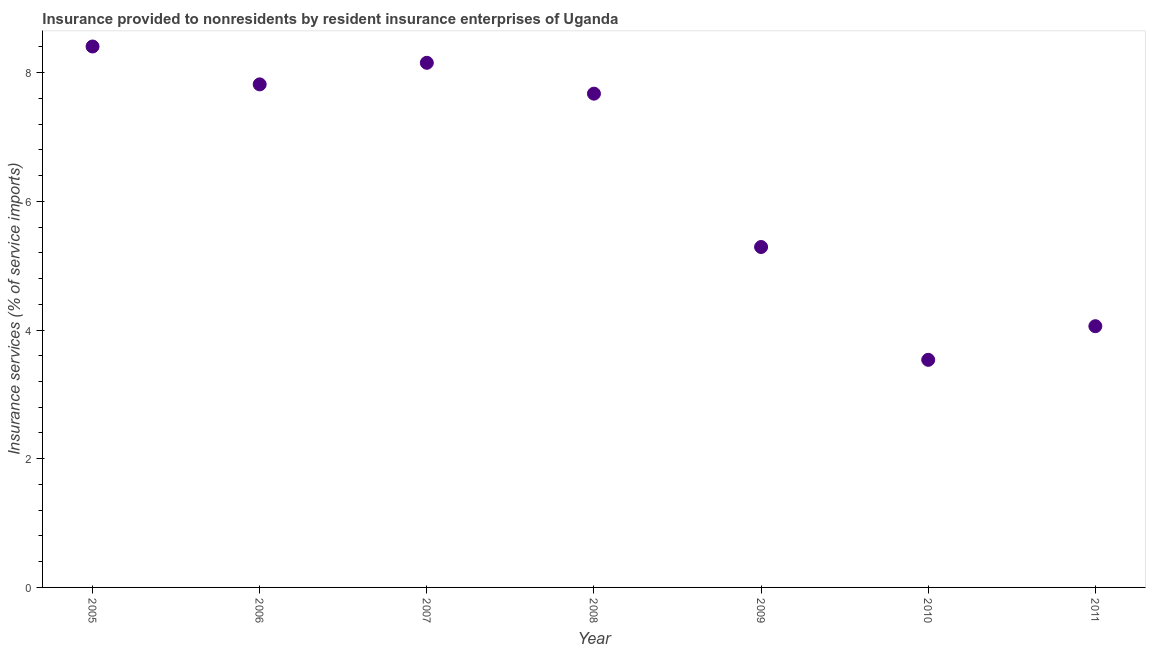What is the insurance and financial services in 2011?
Offer a very short reply. 4.06. Across all years, what is the maximum insurance and financial services?
Offer a terse response. 8.41. Across all years, what is the minimum insurance and financial services?
Provide a succinct answer. 3.54. What is the sum of the insurance and financial services?
Your answer should be very brief. 44.94. What is the difference between the insurance and financial services in 2007 and 2010?
Ensure brevity in your answer.  4.62. What is the average insurance and financial services per year?
Keep it short and to the point. 6.42. What is the median insurance and financial services?
Your response must be concise. 7.67. What is the ratio of the insurance and financial services in 2005 to that in 2007?
Your response must be concise. 1.03. Is the insurance and financial services in 2010 less than that in 2011?
Ensure brevity in your answer.  Yes. Is the difference between the insurance and financial services in 2005 and 2011 greater than the difference between any two years?
Make the answer very short. No. What is the difference between the highest and the second highest insurance and financial services?
Your response must be concise. 0.25. What is the difference between the highest and the lowest insurance and financial services?
Provide a short and direct response. 4.87. In how many years, is the insurance and financial services greater than the average insurance and financial services taken over all years?
Give a very brief answer. 4. How many dotlines are there?
Offer a terse response. 1. How many years are there in the graph?
Your answer should be compact. 7. What is the difference between two consecutive major ticks on the Y-axis?
Your answer should be very brief. 2. Does the graph contain any zero values?
Make the answer very short. No. What is the title of the graph?
Offer a terse response. Insurance provided to nonresidents by resident insurance enterprises of Uganda. What is the label or title of the X-axis?
Your answer should be compact. Year. What is the label or title of the Y-axis?
Your answer should be compact. Insurance services (% of service imports). What is the Insurance services (% of service imports) in 2005?
Give a very brief answer. 8.41. What is the Insurance services (% of service imports) in 2006?
Make the answer very short. 7.82. What is the Insurance services (% of service imports) in 2007?
Your answer should be very brief. 8.15. What is the Insurance services (% of service imports) in 2008?
Ensure brevity in your answer.  7.67. What is the Insurance services (% of service imports) in 2009?
Keep it short and to the point. 5.29. What is the Insurance services (% of service imports) in 2010?
Ensure brevity in your answer.  3.54. What is the Insurance services (% of service imports) in 2011?
Keep it short and to the point. 4.06. What is the difference between the Insurance services (% of service imports) in 2005 and 2006?
Offer a very short reply. 0.59. What is the difference between the Insurance services (% of service imports) in 2005 and 2007?
Make the answer very short. 0.25. What is the difference between the Insurance services (% of service imports) in 2005 and 2008?
Offer a terse response. 0.73. What is the difference between the Insurance services (% of service imports) in 2005 and 2009?
Ensure brevity in your answer.  3.12. What is the difference between the Insurance services (% of service imports) in 2005 and 2010?
Give a very brief answer. 4.87. What is the difference between the Insurance services (% of service imports) in 2005 and 2011?
Offer a very short reply. 4.35. What is the difference between the Insurance services (% of service imports) in 2006 and 2007?
Keep it short and to the point. -0.34. What is the difference between the Insurance services (% of service imports) in 2006 and 2008?
Ensure brevity in your answer.  0.14. What is the difference between the Insurance services (% of service imports) in 2006 and 2009?
Your response must be concise. 2.53. What is the difference between the Insurance services (% of service imports) in 2006 and 2010?
Offer a very short reply. 4.28. What is the difference between the Insurance services (% of service imports) in 2006 and 2011?
Give a very brief answer. 3.76. What is the difference between the Insurance services (% of service imports) in 2007 and 2008?
Your response must be concise. 0.48. What is the difference between the Insurance services (% of service imports) in 2007 and 2009?
Your answer should be compact. 2.86. What is the difference between the Insurance services (% of service imports) in 2007 and 2010?
Make the answer very short. 4.62. What is the difference between the Insurance services (% of service imports) in 2007 and 2011?
Keep it short and to the point. 4.09. What is the difference between the Insurance services (% of service imports) in 2008 and 2009?
Keep it short and to the point. 2.38. What is the difference between the Insurance services (% of service imports) in 2008 and 2010?
Offer a terse response. 4.14. What is the difference between the Insurance services (% of service imports) in 2008 and 2011?
Your answer should be compact. 3.61. What is the difference between the Insurance services (% of service imports) in 2009 and 2010?
Ensure brevity in your answer.  1.75. What is the difference between the Insurance services (% of service imports) in 2009 and 2011?
Your response must be concise. 1.23. What is the difference between the Insurance services (% of service imports) in 2010 and 2011?
Provide a succinct answer. -0.52. What is the ratio of the Insurance services (% of service imports) in 2005 to that in 2006?
Make the answer very short. 1.07. What is the ratio of the Insurance services (% of service imports) in 2005 to that in 2007?
Offer a very short reply. 1.03. What is the ratio of the Insurance services (% of service imports) in 2005 to that in 2008?
Your answer should be very brief. 1.1. What is the ratio of the Insurance services (% of service imports) in 2005 to that in 2009?
Offer a very short reply. 1.59. What is the ratio of the Insurance services (% of service imports) in 2005 to that in 2010?
Keep it short and to the point. 2.38. What is the ratio of the Insurance services (% of service imports) in 2005 to that in 2011?
Your answer should be compact. 2.07. What is the ratio of the Insurance services (% of service imports) in 2006 to that in 2007?
Provide a short and direct response. 0.96. What is the ratio of the Insurance services (% of service imports) in 2006 to that in 2009?
Provide a succinct answer. 1.48. What is the ratio of the Insurance services (% of service imports) in 2006 to that in 2010?
Make the answer very short. 2.21. What is the ratio of the Insurance services (% of service imports) in 2006 to that in 2011?
Your answer should be very brief. 1.93. What is the ratio of the Insurance services (% of service imports) in 2007 to that in 2008?
Provide a short and direct response. 1.06. What is the ratio of the Insurance services (% of service imports) in 2007 to that in 2009?
Keep it short and to the point. 1.54. What is the ratio of the Insurance services (% of service imports) in 2007 to that in 2010?
Make the answer very short. 2.31. What is the ratio of the Insurance services (% of service imports) in 2007 to that in 2011?
Offer a terse response. 2.01. What is the ratio of the Insurance services (% of service imports) in 2008 to that in 2009?
Provide a succinct answer. 1.45. What is the ratio of the Insurance services (% of service imports) in 2008 to that in 2010?
Your answer should be compact. 2.17. What is the ratio of the Insurance services (% of service imports) in 2008 to that in 2011?
Offer a terse response. 1.89. What is the ratio of the Insurance services (% of service imports) in 2009 to that in 2010?
Your answer should be very brief. 1.5. What is the ratio of the Insurance services (% of service imports) in 2009 to that in 2011?
Your answer should be very brief. 1.3. What is the ratio of the Insurance services (% of service imports) in 2010 to that in 2011?
Ensure brevity in your answer.  0.87. 